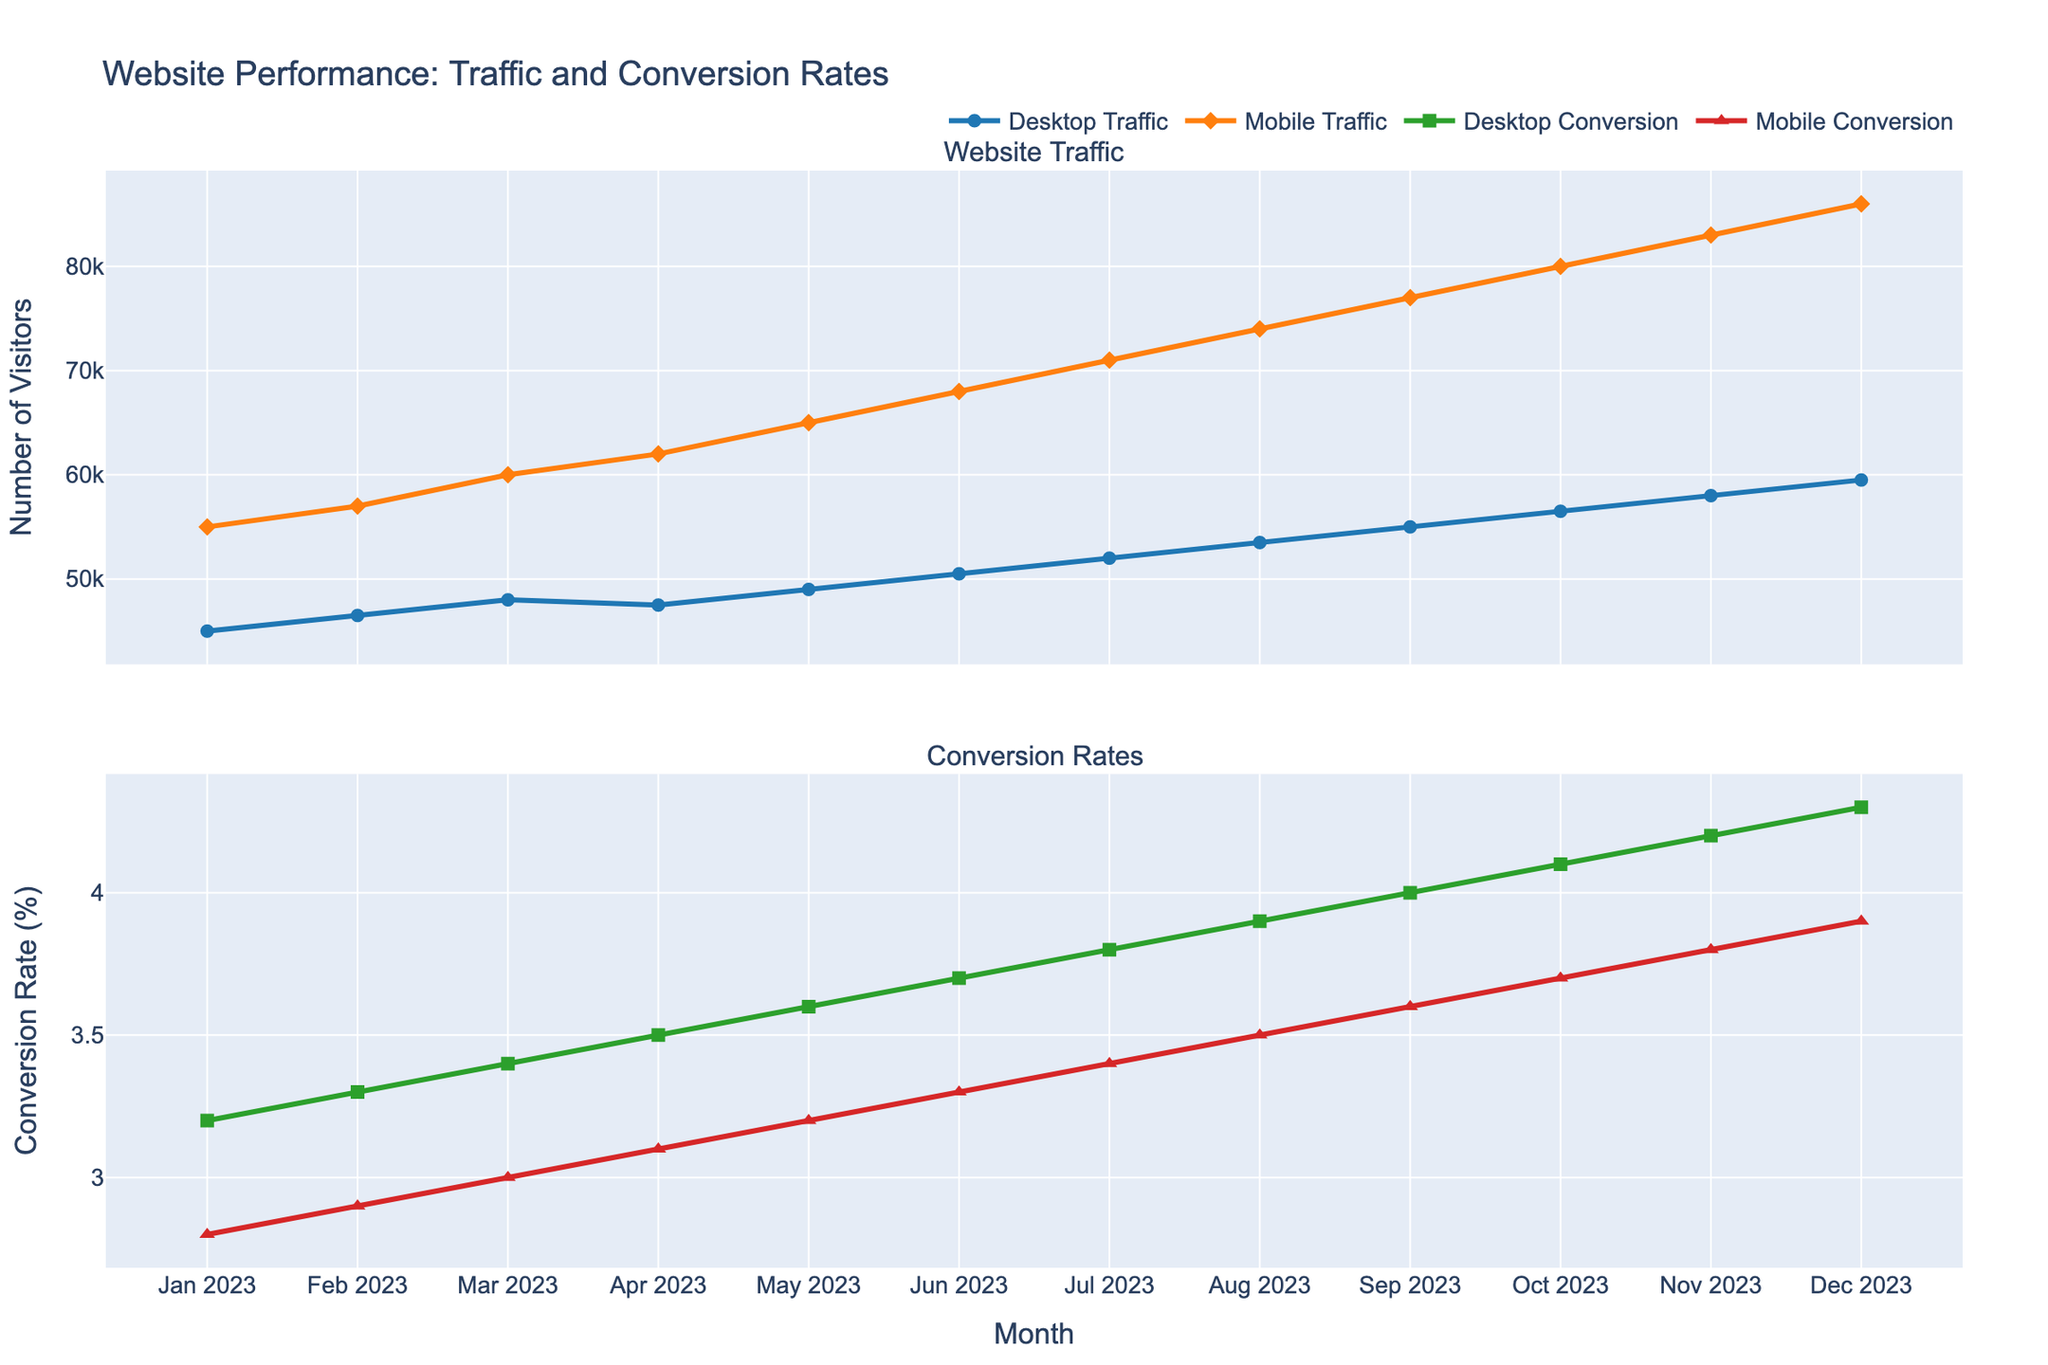What is the overall trend in mobile traffic from January 2023 to December 2023? Mobile traffic has shown a clear upward trend over the months. Starting from 55,000 in January 2023, it increases consistently every month, reaching 86,000 by December 2023.
Answer: Upward trend Which month had the highest desktop conversion rate? The desktop conversion rate is highest in December 2023 where it reaches 4.3%. This is evident from the topmost point on the line for desktop conversion rates.
Answer: December 2023 How does the increase in desktop traffic from January 2023 to December 2023 compare to the increase in mobile traffic over the same period? Desktop traffic increases from 45,000 to 59,500, an increase of 14,500. Mobile traffic increases from 55,000 to 86,000, an increase of 31,000. Therefore, the increase in mobile traffic is significantly greater.
Answer: Mobile traffic increased more In which month did mobile conversion rates surpass 3%? The mobile conversion rate first surpasses 3% in March 2023, where it reaches exactly 3.0%. This can be seen where the red line passes the 3% mark.
Answer: March 2023 By how much did the desktop conversion rate increase from January 2023 to December 2023? In January 2023, the desktop conversion rate was 3.2%, and in December 2023, it reached 4.3%. The increase is 4.3% - 3.2% = 1.1%.
Answer: 1.1% Which type of user showed a higher conversion rate in October 2023? In October 2023, the desktop conversion rate was 4.1% while the mobile conversion rate was 3.7%. Therefore, desktop users had a higher conversion rate.
Answer: Desktop users How much did mobile traffic grow on average each month? Mobile traffic grew from 55,000 in January 2023 to 86,000 in December 2023. The growth is 86,000 - 55,000 = 31,000 over 11 months. The average monthly growth is 31,000 / 11 ≈ 2,818.18.
Answer: ~2,818 Compare the conversion rates of desktop and mobile users in July 2023. In July 2023, the desktop conversion rate was 3.8% and the mobile conversion rate was 3.4%. Therefore, the desktop conversion rate was higher.
Answer: Desktop higher What noticeable pattern can be observed in both the desktop and mobile traffic numbers over the months? Both desktop and mobile traffic numbers increase consistently month-over-month from January 2023 to December 2023. This steady increase is visually apparent in the line chart.
Answer: Consistent increase 